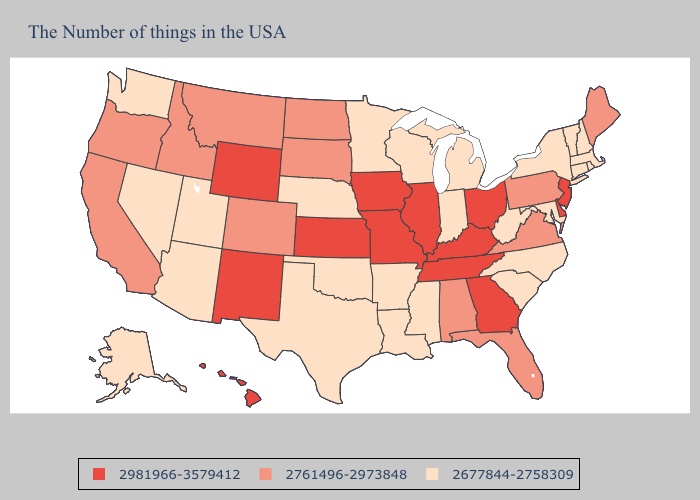Name the states that have a value in the range 2981966-3579412?
Quick response, please. New Jersey, Delaware, Ohio, Georgia, Kentucky, Tennessee, Illinois, Missouri, Iowa, Kansas, Wyoming, New Mexico, Hawaii. Does New Jersey have the lowest value in the Northeast?
Short answer required. No. Does Maine have the highest value in the Northeast?
Answer briefly. No. Does the map have missing data?
Be succinct. No. Among the states that border Louisiana , which have the highest value?
Quick response, please. Mississippi, Arkansas, Texas. What is the lowest value in the USA?
Short answer required. 2677844-2758309. Name the states that have a value in the range 2677844-2758309?
Answer briefly. Massachusetts, Rhode Island, New Hampshire, Vermont, Connecticut, New York, Maryland, North Carolina, South Carolina, West Virginia, Michigan, Indiana, Wisconsin, Mississippi, Louisiana, Arkansas, Minnesota, Nebraska, Oklahoma, Texas, Utah, Arizona, Nevada, Washington, Alaska. Name the states that have a value in the range 2981966-3579412?
Concise answer only. New Jersey, Delaware, Ohio, Georgia, Kentucky, Tennessee, Illinois, Missouri, Iowa, Kansas, Wyoming, New Mexico, Hawaii. What is the lowest value in states that border Connecticut?
Keep it brief. 2677844-2758309. What is the value of Virginia?
Write a very short answer. 2761496-2973848. Is the legend a continuous bar?
Quick response, please. No. Does Delaware have the highest value in the South?
Short answer required. Yes. Among the states that border Tennessee , which have the lowest value?
Concise answer only. North Carolina, Mississippi, Arkansas. How many symbols are there in the legend?
Short answer required. 3. 